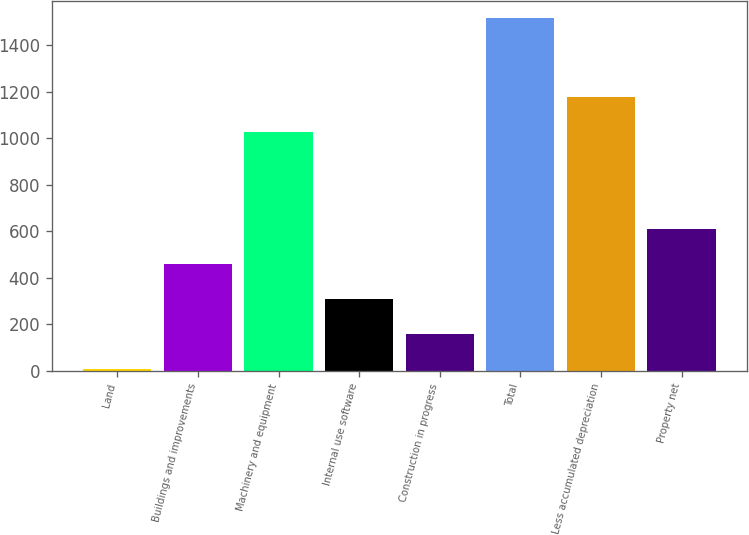Convert chart to OTSL. <chart><loc_0><loc_0><loc_500><loc_500><bar_chart><fcel>Land<fcel>Buildings and improvements<fcel>Machinery and equipment<fcel>Internal use software<fcel>Construction in progress<fcel>Total<fcel>Less accumulated depreciation<fcel>Property net<nl><fcel>5.1<fcel>458.28<fcel>1028.4<fcel>307.22<fcel>156.16<fcel>1515.7<fcel>1179.46<fcel>609.34<nl></chart> 